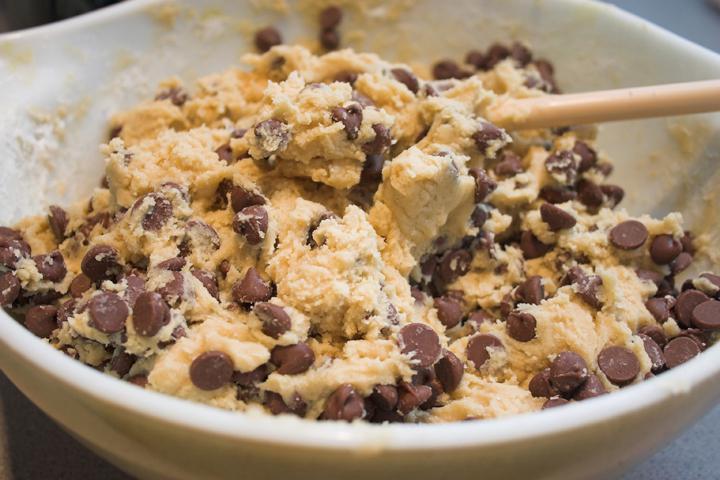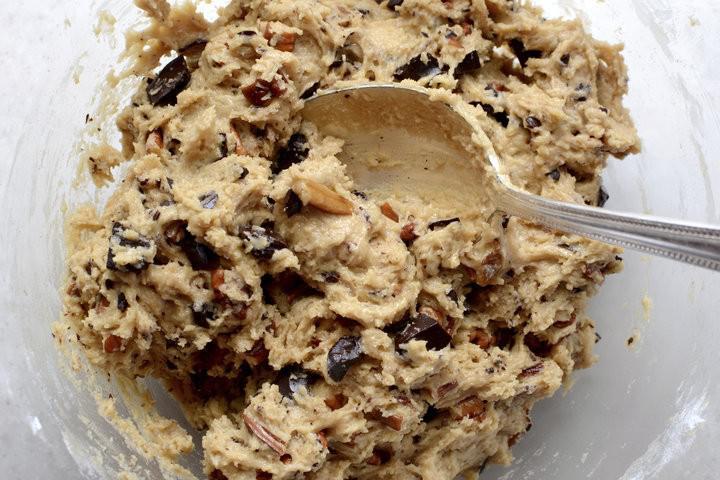The first image is the image on the left, the second image is the image on the right. Considering the images on both sides, is "Each image includes raw cookie dough, and at least one image includes raw cookie dough in a round bowl and a spoon with cookie dough on it." valid? Answer yes or no. Yes. The first image is the image on the left, the second image is the image on the right. Analyze the images presented: Is the assertion "There is at least one human hand visible here." valid? Answer yes or no. No. 